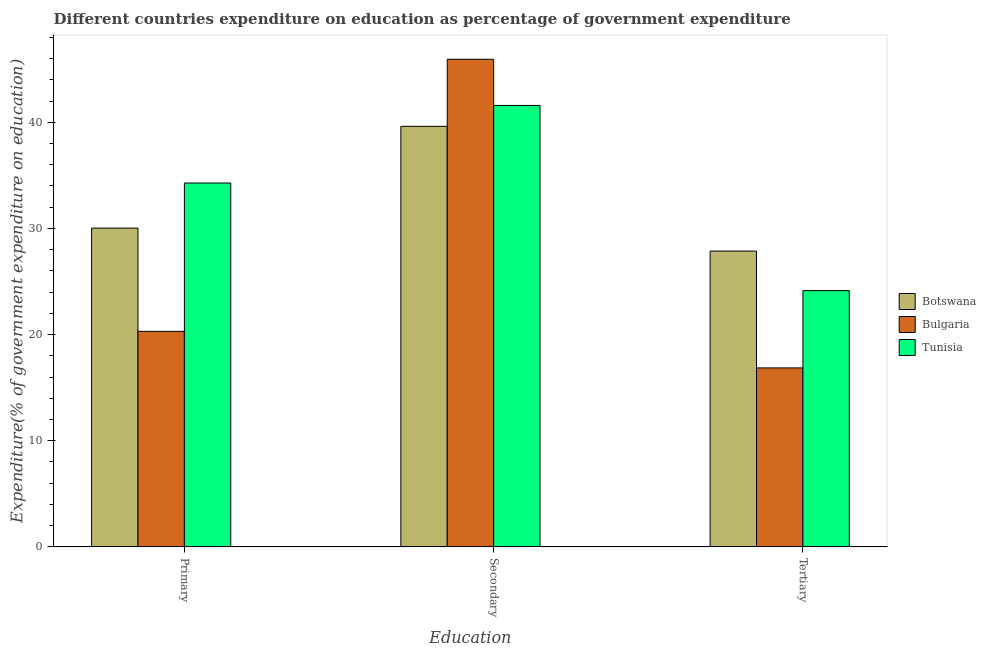How many groups of bars are there?
Give a very brief answer. 3. How many bars are there on the 3rd tick from the right?
Make the answer very short. 3. What is the label of the 2nd group of bars from the left?
Ensure brevity in your answer.  Secondary. What is the expenditure on secondary education in Bulgaria?
Your response must be concise. 45.94. Across all countries, what is the maximum expenditure on primary education?
Your answer should be very brief. 34.28. Across all countries, what is the minimum expenditure on secondary education?
Your answer should be very brief. 39.62. What is the total expenditure on primary education in the graph?
Offer a very short reply. 84.61. What is the difference between the expenditure on primary education in Bulgaria and that in Botswana?
Your answer should be very brief. -9.73. What is the difference between the expenditure on tertiary education in Botswana and the expenditure on secondary education in Bulgaria?
Keep it short and to the point. -18.07. What is the average expenditure on secondary education per country?
Provide a short and direct response. 42.38. What is the difference between the expenditure on primary education and expenditure on tertiary education in Tunisia?
Offer a terse response. 10.14. What is the ratio of the expenditure on tertiary education in Bulgaria to that in Tunisia?
Your answer should be very brief. 0.7. Is the difference between the expenditure on tertiary education in Tunisia and Bulgaria greater than the difference between the expenditure on secondary education in Tunisia and Bulgaria?
Your answer should be very brief. Yes. What is the difference between the highest and the second highest expenditure on primary education?
Your response must be concise. 4.25. What is the difference between the highest and the lowest expenditure on tertiary education?
Ensure brevity in your answer.  11.01. In how many countries, is the expenditure on tertiary education greater than the average expenditure on tertiary education taken over all countries?
Offer a terse response. 2. Is the sum of the expenditure on secondary education in Bulgaria and Botswana greater than the maximum expenditure on tertiary education across all countries?
Ensure brevity in your answer.  Yes. What does the 3rd bar from the left in Primary represents?
Your answer should be compact. Tunisia. What does the 1st bar from the right in Secondary represents?
Ensure brevity in your answer.  Tunisia. How many bars are there?
Offer a very short reply. 9. How many countries are there in the graph?
Offer a terse response. 3. Does the graph contain any zero values?
Ensure brevity in your answer.  No. Does the graph contain grids?
Your answer should be compact. No. How many legend labels are there?
Give a very brief answer. 3. How are the legend labels stacked?
Your response must be concise. Vertical. What is the title of the graph?
Provide a short and direct response. Different countries expenditure on education as percentage of government expenditure. What is the label or title of the X-axis?
Give a very brief answer. Education. What is the label or title of the Y-axis?
Ensure brevity in your answer.  Expenditure(% of government expenditure on education). What is the Expenditure(% of government expenditure on education) of Botswana in Primary?
Your answer should be very brief. 30.03. What is the Expenditure(% of government expenditure on education) of Bulgaria in Primary?
Keep it short and to the point. 20.3. What is the Expenditure(% of government expenditure on education) in Tunisia in Primary?
Your answer should be compact. 34.28. What is the Expenditure(% of government expenditure on education) of Botswana in Secondary?
Offer a terse response. 39.62. What is the Expenditure(% of government expenditure on education) in Bulgaria in Secondary?
Your response must be concise. 45.94. What is the Expenditure(% of government expenditure on education) in Tunisia in Secondary?
Give a very brief answer. 41.58. What is the Expenditure(% of government expenditure on education) of Botswana in Tertiary?
Your answer should be compact. 27.87. What is the Expenditure(% of government expenditure on education) of Bulgaria in Tertiary?
Give a very brief answer. 16.86. What is the Expenditure(% of government expenditure on education) of Tunisia in Tertiary?
Provide a short and direct response. 24.14. Across all Education, what is the maximum Expenditure(% of government expenditure on education) in Botswana?
Your response must be concise. 39.62. Across all Education, what is the maximum Expenditure(% of government expenditure on education) in Bulgaria?
Make the answer very short. 45.94. Across all Education, what is the maximum Expenditure(% of government expenditure on education) in Tunisia?
Ensure brevity in your answer.  41.58. Across all Education, what is the minimum Expenditure(% of government expenditure on education) in Botswana?
Provide a succinct answer. 27.87. Across all Education, what is the minimum Expenditure(% of government expenditure on education) in Bulgaria?
Provide a short and direct response. 16.86. Across all Education, what is the minimum Expenditure(% of government expenditure on education) in Tunisia?
Offer a terse response. 24.14. What is the total Expenditure(% of government expenditure on education) in Botswana in the graph?
Offer a terse response. 97.51. What is the total Expenditure(% of government expenditure on education) in Bulgaria in the graph?
Provide a succinct answer. 83.1. What is the total Expenditure(% of government expenditure on education) in Tunisia in the graph?
Your response must be concise. 100. What is the difference between the Expenditure(% of government expenditure on education) in Botswana in Primary and that in Secondary?
Provide a short and direct response. -9.59. What is the difference between the Expenditure(% of government expenditure on education) of Bulgaria in Primary and that in Secondary?
Your answer should be compact. -25.64. What is the difference between the Expenditure(% of government expenditure on education) in Tunisia in Primary and that in Secondary?
Keep it short and to the point. -7.31. What is the difference between the Expenditure(% of government expenditure on education) in Botswana in Primary and that in Tertiary?
Give a very brief answer. 2.16. What is the difference between the Expenditure(% of government expenditure on education) of Bulgaria in Primary and that in Tertiary?
Your response must be concise. 3.44. What is the difference between the Expenditure(% of government expenditure on education) in Tunisia in Primary and that in Tertiary?
Keep it short and to the point. 10.14. What is the difference between the Expenditure(% of government expenditure on education) of Botswana in Secondary and that in Tertiary?
Give a very brief answer. 11.75. What is the difference between the Expenditure(% of government expenditure on education) of Bulgaria in Secondary and that in Tertiary?
Your response must be concise. 29.08. What is the difference between the Expenditure(% of government expenditure on education) in Tunisia in Secondary and that in Tertiary?
Your answer should be compact. 17.44. What is the difference between the Expenditure(% of government expenditure on education) of Botswana in Primary and the Expenditure(% of government expenditure on education) of Bulgaria in Secondary?
Offer a very short reply. -15.9. What is the difference between the Expenditure(% of government expenditure on education) in Botswana in Primary and the Expenditure(% of government expenditure on education) in Tunisia in Secondary?
Make the answer very short. -11.55. What is the difference between the Expenditure(% of government expenditure on education) of Bulgaria in Primary and the Expenditure(% of government expenditure on education) of Tunisia in Secondary?
Your answer should be very brief. -21.28. What is the difference between the Expenditure(% of government expenditure on education) of Botswana in Primary and the Expenditure(% of government expenditure on education) of Bulgaria in Tertiary?
Make the answer very short. 13.17. What is the difference between the Expenditure(% of government expenditure on education) in Botswana in Primary and the Expenditure(% of government expenditure on education) in Tunisia in Tertiary?
Keep it short and to the point. 5.89. What is the difference between the Expenditure(% of government expenditure on education) in Bulgaria in Primary and the Expenditure(% of government expenditure on education) in Tunisia in Tertiary?
Make the answer very short. -3.84. What is the difference between the Expenditure(% of government expenditure on education) of Botswana in Secondary and the Expenditure(% of government expenditure on education) of Bulgaria in Tertiary?
Your response must be concise. 22.76. What is the difference between the Expenditure(% of government expenditure on education) in Botswana in Secondary and the Expenditure(% of government expenditure on education) in Tunisia in Tertiary?
Your answer should be compact. 15.48. What is the difference between the Expenditure(% of government expenditure on education) in Bulgaria in Secondary and the Expenditure(% of government expenditure on education) in Tunisia in Tertiary?
Give a very brief answer. 21.8. What is the average Expenditure(% of government expenditure on education) of Botswana per Education?
Your answer should be compact. 32.5. What is the average Expenditure(% of government expenditure on education) of Bulgaria per Education?
Ensure brevity in your answer.  27.7. What is the average Expenditure(% of government expenditure on education) in Tunisia per Education?
Make the answer very short. 33.33. What is the difference between the Expenditure(% of government expenditure on education) of Botswana and Expenditure(% of government expenditure on education) of Bulgaria in Primary?
Offer a very short reply. 9.73. What is the difference between the Expenditure(% of government expenditure on education) in Botswana and Expenditure(% of government expenditure on education) in Tunisia in Primary?
Give a very brief answer. -4.25. What is the difference between the Expenditure(% of government expenditure on education) in Bulgaria and Expenditure(% of government expenditure on education) in Tunisia in Primary?
Your answer should be compact. -13.98. What is the difference between the Expenditure(% of government expenditure on education) in Botswana and Expenditure(% of government expenditure on education) in Bulgaria in Secondary?
Offer a very short reply. -6.32. What is the difference between the Expenditure(% of government expenditure on education) of Botswana and Expenditure(% of government expenditure on education) of Tunisia in Secondary?
Give a very brief answer. -1.97. What is the difference between the Expenditure(% of government expenditure on education) in Bulgaria and Expenditure(% of government expenditure on education) in Tunisia in Secondary?
Keep it short and to the point. 4.35. What is the difference between the Expenditure(% of government expenditure on education) of Botswana and Expenditure(% of government expenditure on education) of Bulgaria in Tertiary?
Offer a very short reply. 11.01. What is the difference between the Expenditure(% of government expenditure on education) in Botswana and Expenditure(% of government expenditure on education) in Tunisia in Tertiary?
Your response must be concise. 3.73. What is the difference between the Expenditure(% of government expenditure on education) of Bulgaria and Expenditure(% of government expenditure on education) of Tunisia in Tertiary?
Your answer should be compact. -7.28. What is the ratio of the Expenditure(% of government expenditure on education) of Botswana in Primary to that in Secondary?
Your response must be concise. 0.76. What is the ratio of the Expenditure(% of government expenditure on education) of Bulgaria in Primary to that in Secondary?
Provide a succinct answer. 0.44. What is the ratio of the Expenditure(% of government expenditure on education) in Tunisia in Primary to that in Secondary?
Offer a very short reply. 0.82. What is the ratio of the Expenditure(% of government expenditure on education) of Botswana in Primary to that in Tertiary?
Your answer should be very brief. 1.08. What is the ratio of the Expenditure(% of government expenditure on education) in Bulgaria in Primary to that in Tertiary?
Make the answer very short. 1.2. What is the ratio of the Expenditure(% of government expenditure on education) of Tunisia in Primary to that in Tertiary?
Offer a terse response. 1.42. What is the ratio of the Expenditure(% of government expenditure on education) of Botswana in Secondary to that in Tertiary?
Your answer should be compact. 1.42. What is the ratio of the Expenditure(% of government expenditure on education) of Bulgaria in Secondary to that in Tertiary?
Your answer should be very brief. 2.72. What is the ratio of the Expenditure(% of government expenditure on education) in Tunisia in Secondary to that in Tertiary?
Your response must be concise. 1.72. What is the difference between the highest and the second highest Expenditure(% of government expenditure on education) of Botswana?
Your response must be concise. 9.59. What is the difference between the highest and the second highest Expenditure(% of government expenditure on education) in Bulgaria?
Make the answer very short. 25.64. What is the difference between the highest and the second highest Expenditure(% of government expenditure on education) of Tunisia?
Make the answer very short. 7.31. What is the difference between the highest and the lowest Expenditure(% of government expenditure on education) of Botswana?
Provide a succinct answer. 11.75. What is the difference between the highest and the lowest Expenditure(% of government expenditure on education) in Bulgaria?
Provide a succinct answer. 29.08. What is the difference between the highest and the lowest Expenditure(% of government expenditure on education) of Tunisia?
Offer a very short reply. 17.44. 